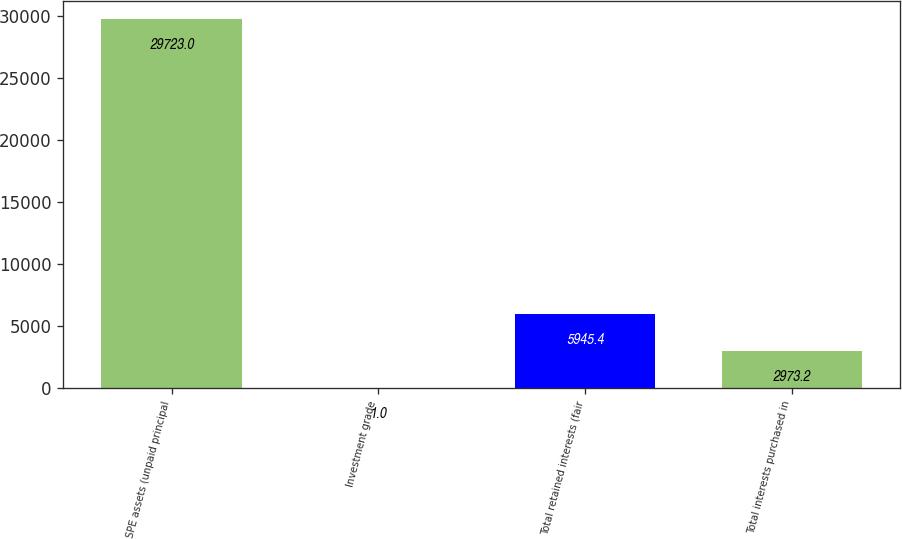<chart> <loc_0><loc_0><loc_500><loc_500><bar_chart><fcel>SPE assets (unpaid principal<fcel>Investment grade<fcel>Total retained interests (fair<fcel>Total interests purchased in<nl><fcel>29723<fcel>1<fcel>5945.4<fcel>2973.2<nl></chart> 